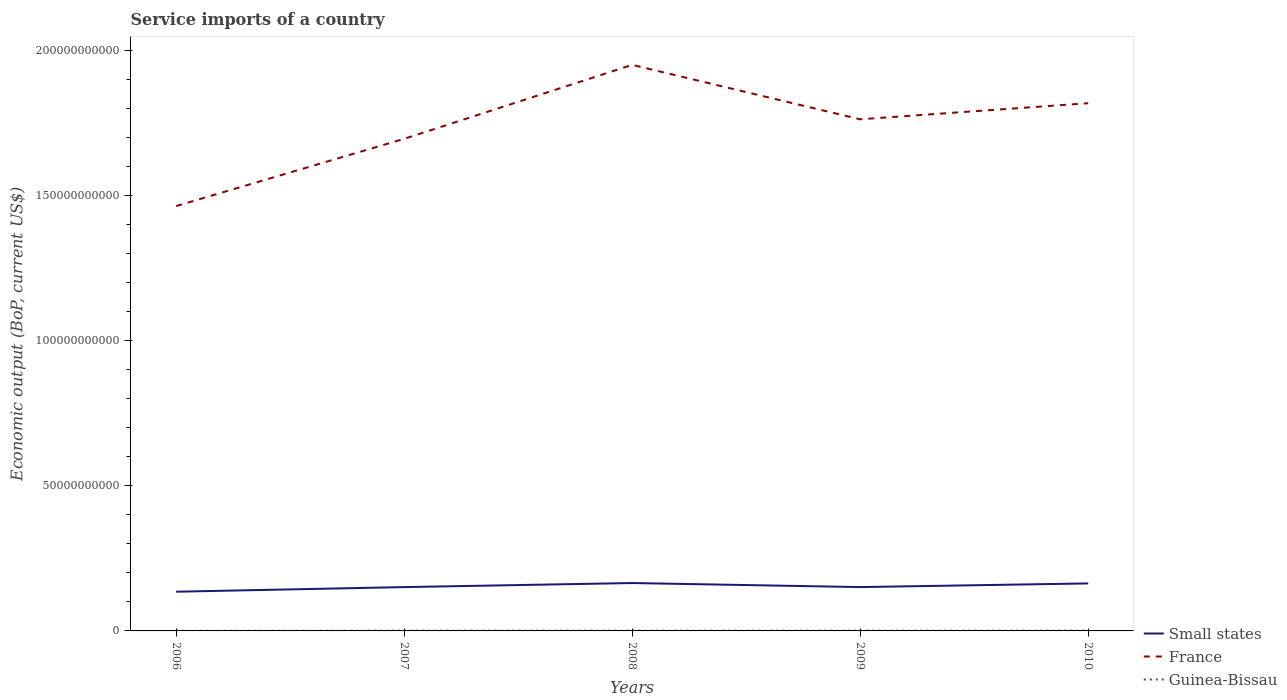Does the line corresponding to Small states intersect with the line corresponding to Guinea-Bissau?
Give a very brief answer. No. Is the number of lines equal to the number of legend labels?
Your answer should be very brief. Yes. Across all years, what is the maximum service imports in Small states?
Offer a terse response. 1.35e+1. What is the total service imports in France in the graph?
Provide a succinct answer. -2.31e+1. What is the difference between the highest and the second highest service imports in Small states?
Offer a very short reply. 2.99e+09. How many lines are there?
Make the answer very short. 3. What is the difference between two consecutive major ticks on the Y-axis?
Your answer should be compact. 5.00e+1. Does the graph contain grids?
Provide a short and direct response. No. How are the legend labels stacked?
Give a very brief answer. Vertical. What is the title of the graph?
Provide a succinct answer. Service imports of a country. Does "Morocco" appear as one of the legend labels in the graph?
Offer a terse response. No. What is the label or title of the Y-axis?
Offer a terse response. Economic output (BoP, current US$). What is the Economic output (BoP, current US$) of Small states in 2006?
Provide a short and direct response. 1.35e+1. What is the Economic output (BoP, current US$) in France in 2006?
Give a very brief answer. 1.46e+11. What is the Economic output (BoP, current US$) in Guinea-Bissau in 2006?
Your response must be concise. 3.96e+07. What is the Economic output (BoP, current US$) in Small states in 2007?
Offer a very short reply. 1.51e+1. What is the Economic output (BoP, current US$) in France in 2007?
Give a very brief answer. 1.69e+11. What is the Economic output (BoP, current US$) in Guinea-Bissau in 2007?
Keep it short and to the point. 6.82e+07. What is the Economic output (BoP, current US$) of Small states in 2008?
Offer a very short reply. 1.65e+1. What is the Economic output (BoP, current US$) of France in 2008?
Make the answer very short. 1.95e+11. What is the Economic output (BoP, current US$) of Guinea-Bissau in 2008?
Your response must be concise. 8.52e+07. What is the Economic output (BoP, current US$) in Small states in 2009?
Keep it short and to the point. 1.51e+1. What is the Economic output (BoP, current US$) of France in 2009?
Your answer should be compact. 1.76e+11. What is the Economic output (BoP, current US$) of Guinea-Bissau in 2009?
Your response must be concise. 8.69e+07. What is the Economic output (BoP, current US$) of Small states in 2010?
Your answer should be compact. 1.64e+1. What is the Economic output (BoP, current US$) of France in 2010?
Give a very brief answer. 1.82e+11. What is the Economic output (BoP, current US$) in Guinea-Bissau in 2010?
Offer a very short reply. 1.03e+08. Across all years, what is the maximum Economic output (BoP, current US$) in Small states?
Provide a succinct answer. 1.65e+1. Across all years, what is the maximum Economic output (BoP, current US$) of France?
Ensure brevity in your answer.  1.95e+11. Across all years, what is the maximum Economic output (BoP, current US$) in Guinea-Bissau?
Make the answer very short. 1.03e+08. Across all years, what is the minimum Economic output (BoP, current US$) of Small states?
Keep it short and to the point. 1.35e+1. Across all years, what is the minimum Economic output (BoP, current US$) of France?
Provide a short and direct response. 1.46e+11. Across all years, what is the minimum Economic output (BoP, current US$) of Guinea-Bissau?
Offer a terse response. 3.96e+07. What is the total Economic output (BoP, current US$) in Small states in the graph?
Keep it short and to the point. 7.65e+1. What is the total Economic output (BoP, current US$) of France in the graph?
Ensure brevity in your answer.  8.68e+11. What is the total Economic output (BoP, current US$) of Guinea-Bissau in the graph?
Offer a terse response. 3.82e+08. What is the difference between the Economic output (BoP, current US$) in Small states in 2006 and that in 2007?
Provide a short and direct response. -1.58e+09. What is the difference between the Economic output (BoP, current US$) of France in 2006 and that in 2007?
Keep it short and to the point. -2.31e+1. What is the difference between the Economic output (BoP, current US$) of Guinea-Bissau in 2006 and that in 2007?
Keep it short and to the point. -2.87e+07. What is the difference between the Economic output (BoP, current US$) of Small states in 2006 and that in 2008?
Your response must be concise. -2.99e+09. What is the difference between the Economic output (BoP, current US$) in France in 2006 and that in 2008?
Offer a very short reply. -4.86e+1. What is the difference between the Economic output (BoP, current US$) in Guinea-Bissau in 2006 and that in 2008?
Your response must be concise. -4.56e+07. What is the difference between the Economic output (BoP, current US$) of Small states in 2006 and that in 2009?
Keep it short and to the point. -1.59e+09. What is the difference between the Economic output (BoP, current US$) of France in 2006 and that in 2009?
Keep it short and to the point. -2.99e+1. What is the difference between the Economic output (BoP, current US$) of Guinea-Bissau in 2006 and that in 2009?
Provide a short and direct response. -4.73e+07. What is the difference between the Economic output (BoP, current US$) of Small states in 2006 and that in 2010?
Your answer should be very brief. -2.85e+09. What is the difference between the Economic output (BoP, current US$) in France in 2006 and that in 2010?
Your answer should be compact. -3.54e+1. What is the difference between the Economic output (BoP, current US$) of Guinea-Bissau in 2006 and that in 2010?
Keep it short and to the point. -6.30e+07. What is the difference between the Economic output (BoP, current US$) of Small states in 2007 and that in 2008?
Give a very brief answer. -1.40e+09. What is the difference between the Economic output (BoP, current US$) of France in 2007 and that in 2008?
Give a very brief answer. -2.55e+1. What is the difference between the Economic output (BoP, current US$) in Guinea-Bissau in 2007 and that in 2008?
Your answer should be very brief. -1.69e+07. What is the difference between the Economic output (BoP, current US$) in Small states in 2007 and that in 2009?
Your answer should be compact. -9.14e+06. What is the difference between the Economic output (BoP, current US$) in France in 2007 and that in 2009?
Make the answer very short. -6.72e+09. What is the difference between the Economic output (BoP, current US$) of Guinea-Bissau in 2007 and that in 2009?
Make the answer very short. -1.86e+07. What is the difference between the Economic output (BoP, current US$) of Small states in 2007 and that in 2010?
Provide a succinct answer. -1.27e+09. What is the difference between the Economic output (BoP, current US$) of France in 2007 and that in 2010?
Make the answer very short. -1.23e+1. What is the difference between the Economic output (BoP, current US$) of Guinea-Bissau in 2007 and that in 2010?
Offer a very short reply. -3.43e+07. What is the difference between the Economic output (BoP, current US$) of Small states in 2008 and that in 2009?
Keep it short and to the point. 1.39e+09. What is the difference between the Economic output (BoP, current US$) in France in 2008 and that in 2009?
Your answer should be very brief. 1.87e+1. What is the difference between the Economic output (BoP, current US$) in Guinea-Bissau in 2008 and that in 2009?
Your answer should be very brief. -1.70e+06. What is the difference between the Economic output (BoP, current US$) of Small states in 2008 and that in 2010?
Provide a succinct answer. 1.34e+08. What is the difference between the Economic output (BoP, current US$) of France in 2008 and that in 2010?
Offer a terse response. 1.32e+1. What is the difference between the Economic output (BoP, current US$) in Guinea-Bissau in 2008 and that in 2010?
Make the answer very short. -1.74e+07. What is the difference between the Economic output (BoP, current US$) of Small states in 2009 and that in 2010?
Offer a terse response. -1.26e+09. What is the difference between the Economic output (BoP, current US$) of France in 2009 and that in 2010?
Ensure brevity in your answer.  -5.54e+09. What is the difference between the Economic output (BoP, current US$) of Guinea-Bissau in 2009 and that in 2010?
Keep it short and to the point. -1.57e+07. What is the difference between the Economic output (BoP, current US$) in Small states in 2006 and the Economic output (BoP, current US$) in France in 2007?
Give a very brief answer. -1.56e+11. What is the difference between the Economic output (BoP, current US$) of Small states in 2006 and the Economic output (BoP, current US$) of Guinea-Bissau in 2007?
Offer a very short reply. 1.34e+1. What is the difference between the Economic output (BoP, current US$) in France in 2006 and the Economic output (BoP, current US$) in Guinea-Bissau in 2007?
Keep it short and to the point. 1.46e+11. What is the difference between the Economic output (BoP, current US$) in Small states in 2006 and the Economic output (BoP, current US$) in France in 2008?
Offer a very short reply. -1.81e+11. What is the difference between the Economic output (BoP, current US$) in Small states in 2006 and the Economic output (BoP, current US$) in Guinea-Bissau in 2008?
Keep it short and to the point. 1.34e+1. What is the difference between the Economic output (BoP, current US$) in France in 2006 and the Economic output (BoP, current US$) in Guinea-Bissau in 2008?
Your answer should be very brief. 1.46e+11. What is the difference between the Economic output (BoP, current US$) in Small states in 2006 and the Economic output (BoP, current US$) in France in 2009?
Your response must be concise. -1.63e+11. What is the difference between the Economic output (BoP, current US$) of Small states in 2006 and the Economic output (BoP, current US$) of Guinea-Bissau in 2009?
Give a very brief answer. 1.34e+1. What is the difference between the Economic output (BoP, current US$) in France in 2006 and the Economic output (BoP, current US$) in Guinea-Bissau in 2009?
Make the answer very short. 1.46e+11. What is the difference between the Economic output (BoP, current US$) of Small states in 2006 and the Economic output (BoP, current US$) of France in 2010?
Your answer should be very brief. -1.68e+11. What is the difference between the Economic output (BoP, current US$) of Small states in 2006 and the Economic output (BoP, current US$) of Guinea-Bissau in 2010?
Give a very brief answer. 1.34e+1. What is the difference between the Economic output (BoP, current US$) in France in 2006 and the Economic output (BoP, current US$) in Guinea-Bissau in 2010?
Provide a short and direct response. 1.46e+11. What is the difference between the Economic output (BoP, current US$) of Small states in 2007 and the Economic output (BoP, current US$) of France in 2008?
Your answer should be compact. -1.80e+11. What is the difference between the Economic output (BoP, current US$) of Small states in 2007 and the Economic output (BoP, current US$) of Guinea-Bissau in 2008?
Your answer should be compact. 1.50e+1. What is the difference between the Economic output (BoP, current US$) in France in 2007 and the Economic output (BoP, current US$) in Guinea-Bissau in 2008?
Your answer should be very brief. 1.69e+11. What is the difference between the Economic output (BoP, current US$) in Small states in 2007 and the Economic output (BoP, current US$) in France in 2009?
Your answer should be compact. -1.61e+11. What is the difference between the Economic output (BoP, current US$) in Small states in 2007 and the Economic output (BoP, current US$) in Guinea-Bissau in 2009?
Ensure brevity in your answer.  1.50e+1. What is the difference between the Economic output (BoP, current US$) of France in 2007 and the Economic output (BoP, current US$) of Guinea-Bissau in 2009?
Keep it short and to the point. 1.69e+11. What is the difference between the Economic output (BoP, current US$) in Small states in 2007 and the Economic output (BoP, current US$) in France in 2010?
Make the answer very short. -1.67e+11. What is the difference between the Economic output (BoP, current US$) of Small states in 2007 and the Economic output (BoP, current US$) of Guinea-Bissau in 2010?
Provide a short and direct response. 1.50e+1. What is the difference between the Economic output (BoP, current US$) in France in 2007 and the Economic output (BoP, current US$) in Guinea-Bissau in 2010?
Provide a succinct answer. 1.69e+11. What is the difference between the Economic output (BoP, current US$) in Small states in 2008 and the Economic output (BoP, current US$) in France in 2009?
Offer a very short reply. -1.60e+11. What is the difference between the Economic output (BoP, current US$) in Small states in 2008 and the Economic output (BoP, current US$) in Guinea-Bissau in 2009?
Ensure brevity in your answer.  1.64e+1. What is the difference between the Economic output (BoP, current US$) in France in 2008 and the Economic output (BoP, current US$) in Guinea-Bissau in 2009?
Ensure brevity in your answer.  1.95e+11. What is the difference between the Economic output (BoP, current US$) in Small states in 2008 and the Economic output (BoP, current US$) in France in 2010?
Provide a short and direct response. -1.65e+11. What is the difference between the Economic output (BoP, current US$) of Small states in 2008 and the Economic output (BoP, current US$) of Guinea-Bissau in 2010?
Provide a short and direct response. 1.64e+1. What is the difference between the Economic output (BoP, current US$) in France in 2008 and the Economic output (BoP, current US$) in Guinea-Bissau in 2010?
Offer a very short reply. 1.95e+11. What is the difference between the Economic output (BoP, current US$) of Small states in 2009 and the Economic output (BoP, current US$) of France in 2010?
Keep it short and to the point. -1.67e+11. What is the difference between the Economic output (BoP, current US$) of Small states in 2009 and the Economic output (BoP, current US$) of Guinea-Bissau in 2010?
Keep it short and to the point. 1.50e+1. What is the difference between the Economic output (BoP, current US$) of France in 2009 and the Economic output (BoP, current US$) of Guinea-Bissau in 2010?
Provide a succinct answer. 1.76e+11. What is the average Economic output (BoP, current US$) of Small states per year?
Offer a very short reply. 1.53e+1. What is the average Economic output (BoP, current US$) of France per year?
Offer a terse response. 1.74e+11. What is the average Economic output (BoP, current US$) in Guinea-Bissau per year?
Keep it short and to the point. 7.65e+07. In the year 2006, what is the difference between the Economic output (BoP, current US$) in Small states and Economic output (BoP, current US$) in France?
Your answer should be compact. -1.33e+11. In the year 2006, what is the difference between the Economic output (BoP, current US$) of Small states and Economic output (BoP, current US$) of Guinea-Bissau?
Provide a succinct answer. 1.35e+1. In the year 2006, what is the difference between the Economic output (BoP, current US$) in France and Economic output (BoP, current US$) in Guinea-Bissau?
Provide a succinct answer. 1.46e+11. In the year 2007, what is the difference between the Economic output (BoP, current US$) of Small states and Economic output (BoP, current US$) of France?
Offer a terse response. -1.54e+11. In the year 2007, what is the difference between the Economic output (BoP, current US$) of Small states and Economic output (BoP, current US$) of Guinea-Bissau?
Ensure brevity in your answer.  1.50e+1. In the year 2007, what is the difference between the Economic output (BoP, current US$) in France and Economic output (BoP, current US$) in Guinea-Bissau?
Your answer should be very brief. 1.69e+11. In the year 2008, what is the difference between the Economic output (BoP, current US$) in Small states and Economic output (BoP, current US$) in France?
Provide a succinct answer. -1.78e+11. In the year 2008, what is the difference between the Economic output (BoP, current US$) of Small states and Economic output (BoP, current US$) of Guinea-Bissau?
Offer a terse response. 1.64e+1. In the year 2008, what is the difference between the Economic output (BoP, current US$) in France and Economic output (BoP, current US$) in Guinea-Bissau?
Your response must be concise. 1.95e+11. In the year 2009, what is the difference between the Economic output (BoP, current US$) in Small states and Economic output (BoP, current US$) in France?
Make the answer very short. -1.61e+11. In the year 2009, what is the difference between the Economic output (BoP, current US$) of Small states and Economic output (BoP, current US$) of Guinea-Bissau?
Give a very brief answer. 1.50e+1. In the year 2009, what is the difference between the Economic output (BoP, current US$) in France and Economic output (BoP, current US$) in Guinea-Bissau?
Offer a terse response. 1.76e+11. In the year 2010, what is the difference between the Economic output (BoP, current US$) of Small states and Economic output (BoP, current US$) of France?
Offer a very short reply. -1.65e+11. In the year 2010, what is the difference between the Economic output (BoP, current US$) in Small states and Economic output (BoP, current US$) in Guinea-Bissau?
Provide a succinct answer. 1.63e+1. In the year 2010, what is the difference between the Economic output (BoP, current US$) of France and Economic output (BoP, current US$) of Guinea-Bissau?
Provide a short and direct response. 1.82e+11. What is the ratio of the Economic output (BoP, current US$) in Small states in 2006 to that in 2007?
Provide a short and direct response. 0.9. What is the ratio of the Economic output (BoP, current US$) in France in 2006 to that in 2007?
Provide a succinct answer. 0.86. What is the ratio of the Economic output (BoP, current US$) of Guinea-Bissau in 2006 to that in 2007?
Keep it short and to the point. 0.58. What is the ratio of the Economic output (BoP, current US$) in Small states in 2006 to that in 2008?
Your answer should be compact. 0.82. What is the ratio of the Economic output (BoP, current US$) in France in 2006 to that in 2008?
Your answer should be compact. 0.75. What is the ratio of the Economic output (BoP, current US$) in Guinea-Bissau in 2006 to that in 2008?
Your response must be concise. 0.46. What is the ratio of the Economic output (BoP, current US$) of Small states in 2006 to that in 2009?
Offer a terse response. 0.89. What is the ratio of the Economic output (BoP, current US$) of France in 2006 to that in 2009?
Give a very brief answer. 0.83. What is the ratio of the Economic output (BoP, current US$) in Guinea-Bissau in 2006 to that in 2009?
Give a very brief answer. 0.46. What is the ratio of the Economic output (BoP, current US$) of Small states in 2006 to that in 2010?
Your response must be concise. 0.83. What is the ratio of the Economic output (BoP, current US$) in France in 2006 to that in 2010?
Your response must be concise. 0.81. What is the ratio of the Economic output (BoP, current US$) of Guinea-Bissau in 2006 to that in 2010?
Provide a succinct answer. 0.39. What is the ratio of the Economic output (BoP, current US$) of Small states in 2007 to that in 2008?
Your response must be concise. 0.92. What is the ratio of the Economic output (BoP, current US$) of France in 2007 to that in 2008?
Your response must be concise. 0.87. What is the ratio of the Economic output (BoP, current US$) of Guinea-Bissau in 2007 to that in 2008?
Ensure brevity in your answer.  0.8. What is the ratio of the Economic output (BoP, current US$) of France in 2007 to that in 2009?
Ensure brevity in your answer.  0.96. What is the ratio of the Economic output (BoP, current US$) in Guinea-Bissau in 2007 to that in 2009?
Provide a succinct answer. 0.79. What is the ratio of the Economic output (BoP, current US$) of Small states in 2007 to that in 2010?
Offer a terse response. 0.92. What is the ratio of the Economic output (BoP, current US$) of France in 2007 to that in 2010?
Your answer should be compact. 0.93. What is the ratio of the Economic output (BoP, current US$) of Guinea-Bissau in 2007 to that in 2010?
Give a very brief answer. 0.67. What is the ratio of the Economic output (BoP, current US$) of Small states in 2008 to that in 2009?
Give a very brief answer. 1.09. What is the ratio of the Economic output (BoP, current US$) of France in 2008 to that in 2009?
Keep it short and to the point. 1.11. What is the ratio of the Economic output (BoP, current US$) of Guinea-Bissau in 2008 to that in 2009?
Offer a very short reply. 0.98. What is the ratio of the Economic output (BoP, current US$) in Small states in 2008 to that in 2010?
Ensure brevity in your answer.  1.01. What is the ratio of the Economic output (BoP, current US$) of France in 2008 to that in 2010?
Keep it short and to the point. 1.07. What is the ratio of the Economic output (BoP, current US$) of Guinea-Bissau in 2008 to that in 2010?
Make the answer very short. 0.83. What is the ratio of the Economic output (BoP, current US$) in Small states in 2009 to that in 2010?
Provide a succinct answer. 0.92. What is the ratio of the Economic output (BoP, current US$) in France in 2009 to that in 2010?
Offer a terse response. 0.97. What is the ratio of the Economic output (BoP, current US$) of Guinea-Bissau in 2009 to that in 2010?
Make the answer very short. 0.85. What is the difference between the highest and the second highest Economic output (BoP, current US$) of Small states?
Your response must be concise. 1.34e+08. What is the difference between the highest and the second highest Economic output (BoP, current US$) of France?
Your response must be concise. 1.32e+1. What is the difference between the highest and the second highest Economic output (BoP, current US$) of Guinea-Bissau?
Provide a succinct answer. 1.57e+07. What is the difference between the highest and the lowest Economic output (BoP, current US$) of Small states?
Ensure brevity in your answer.  2.99e+09. What is the difference between the highest and the lowest Economic output (BoP, current US$) in France?
Keep it short and to the point. 4.86e+1. What is the difference between the highest and the lowest Economic output (BoP, current US$) of Guinea-Bissau?
Offer a terse response. 6.30e+07. 